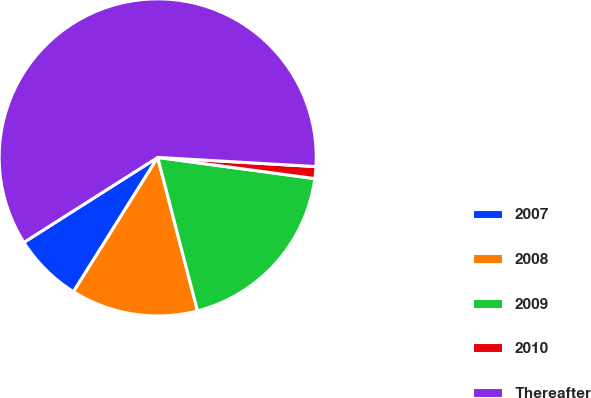Convert chart. <chart><loc_0><loc_0><loc_500><loc_500><pie_chart><fcel>2007<fcel>2008<fcel>2009<fcel>2010<fcel>Thereafter<nl><fcel>7.08%<fcel>12.95%<fcel>18.83%<fcel>1.21%<fcel>59.93%<nl></chart> 